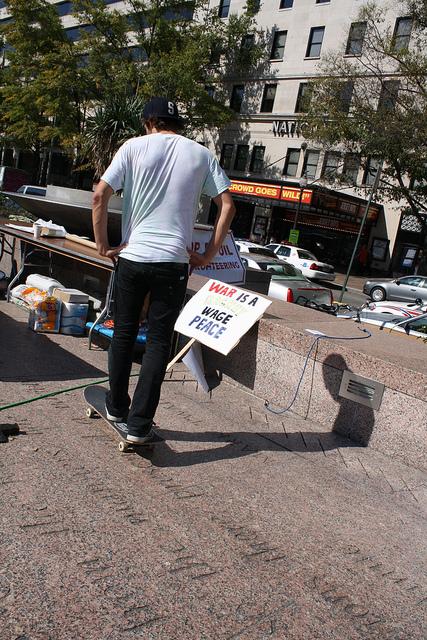What is the last letter that is the same on both lines of the sign?
Give a very brief answer. E. How many people are in the photo?
Give a very brief answer. 1. Is the man with the sign left-wing or right-wing?
Answer briefly. Left-wing. What is written on the piece of the sideboard?
Short answer required. War is wage peace. Is the road narrow?
Quick response, please. No. What color is the building?
Be succinct. Gray. 